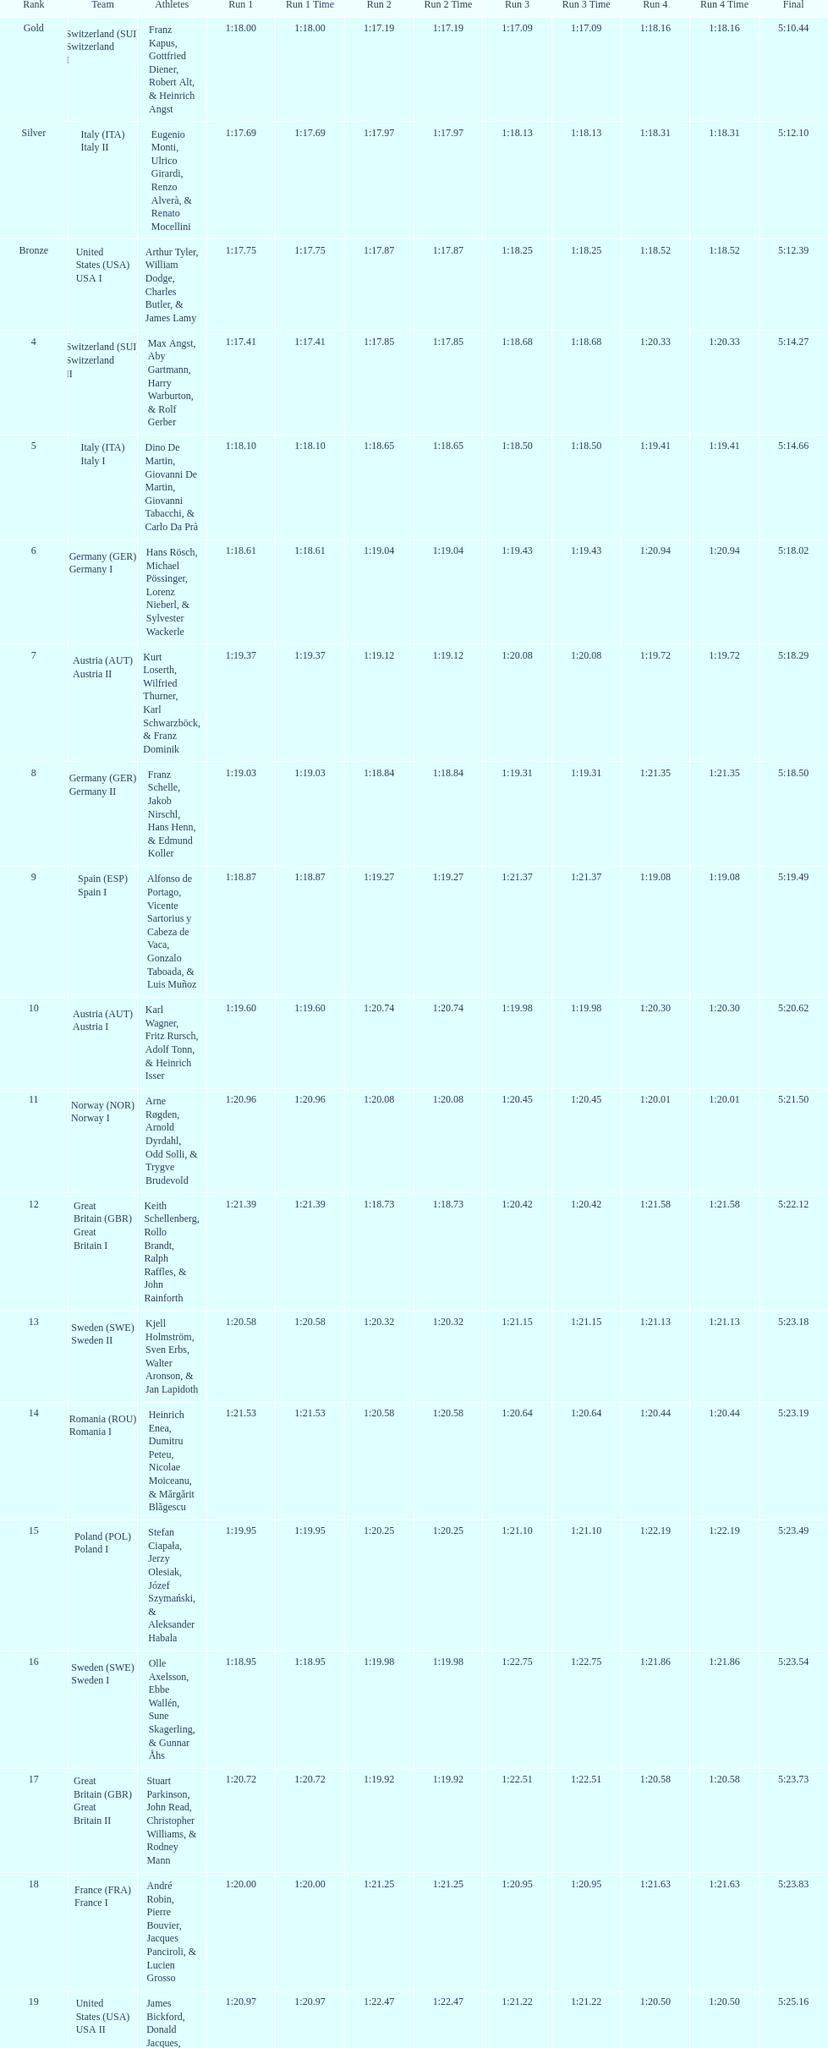Who is the previous team to italy (ita) italy ii? Switzerland (SUI) Switzerland I. 